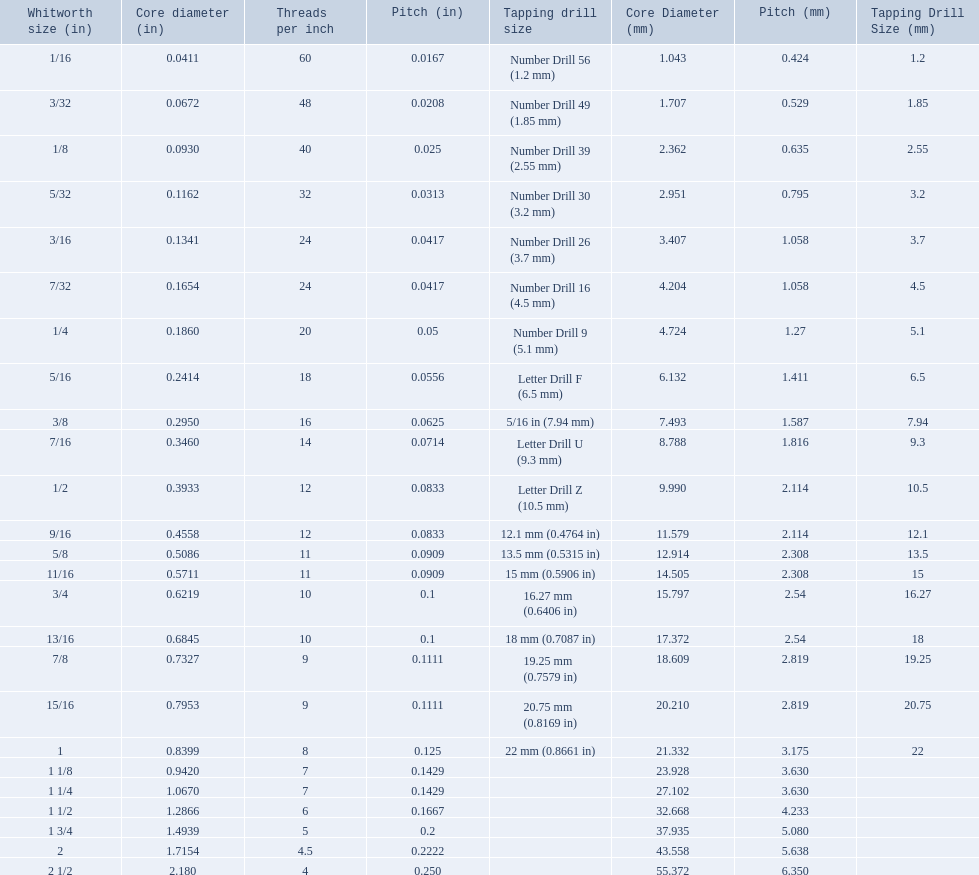What are the standard whitworth sizes in inches? 1/16, 3/32, 1/8, 5/32, 3/16, 7/32, 1/4, 5/16, 3/8, 7/16, 1/2, 9/16, 5/8, 11/16, 3/4, 13/16, 7/8, 15/16, 1, 1 1/8, 1 1/4, 1 1/2, 1 3/4, 2, 2 1/2. How many threads per inch does the 3/16 size have? 24. Which size (in inches) has the same number of threads? 7/32. What are all of the whitworth sizes in the british standard whitworth? 1/16, 3/32, 1/8, 5/32, 3/16, 7/32, 1/4, 5/16, 3/8, 7/16, 1/2, 9/16, 5/8, 11/16, 3/4, 13/16, 7/8, 15/16, 1, 1 1/8, 1 1/4, 1 1/2, 1 3/4, 2, 2 1/2. Which of these sizes uses a tapping drill size of 26? 3/16. 